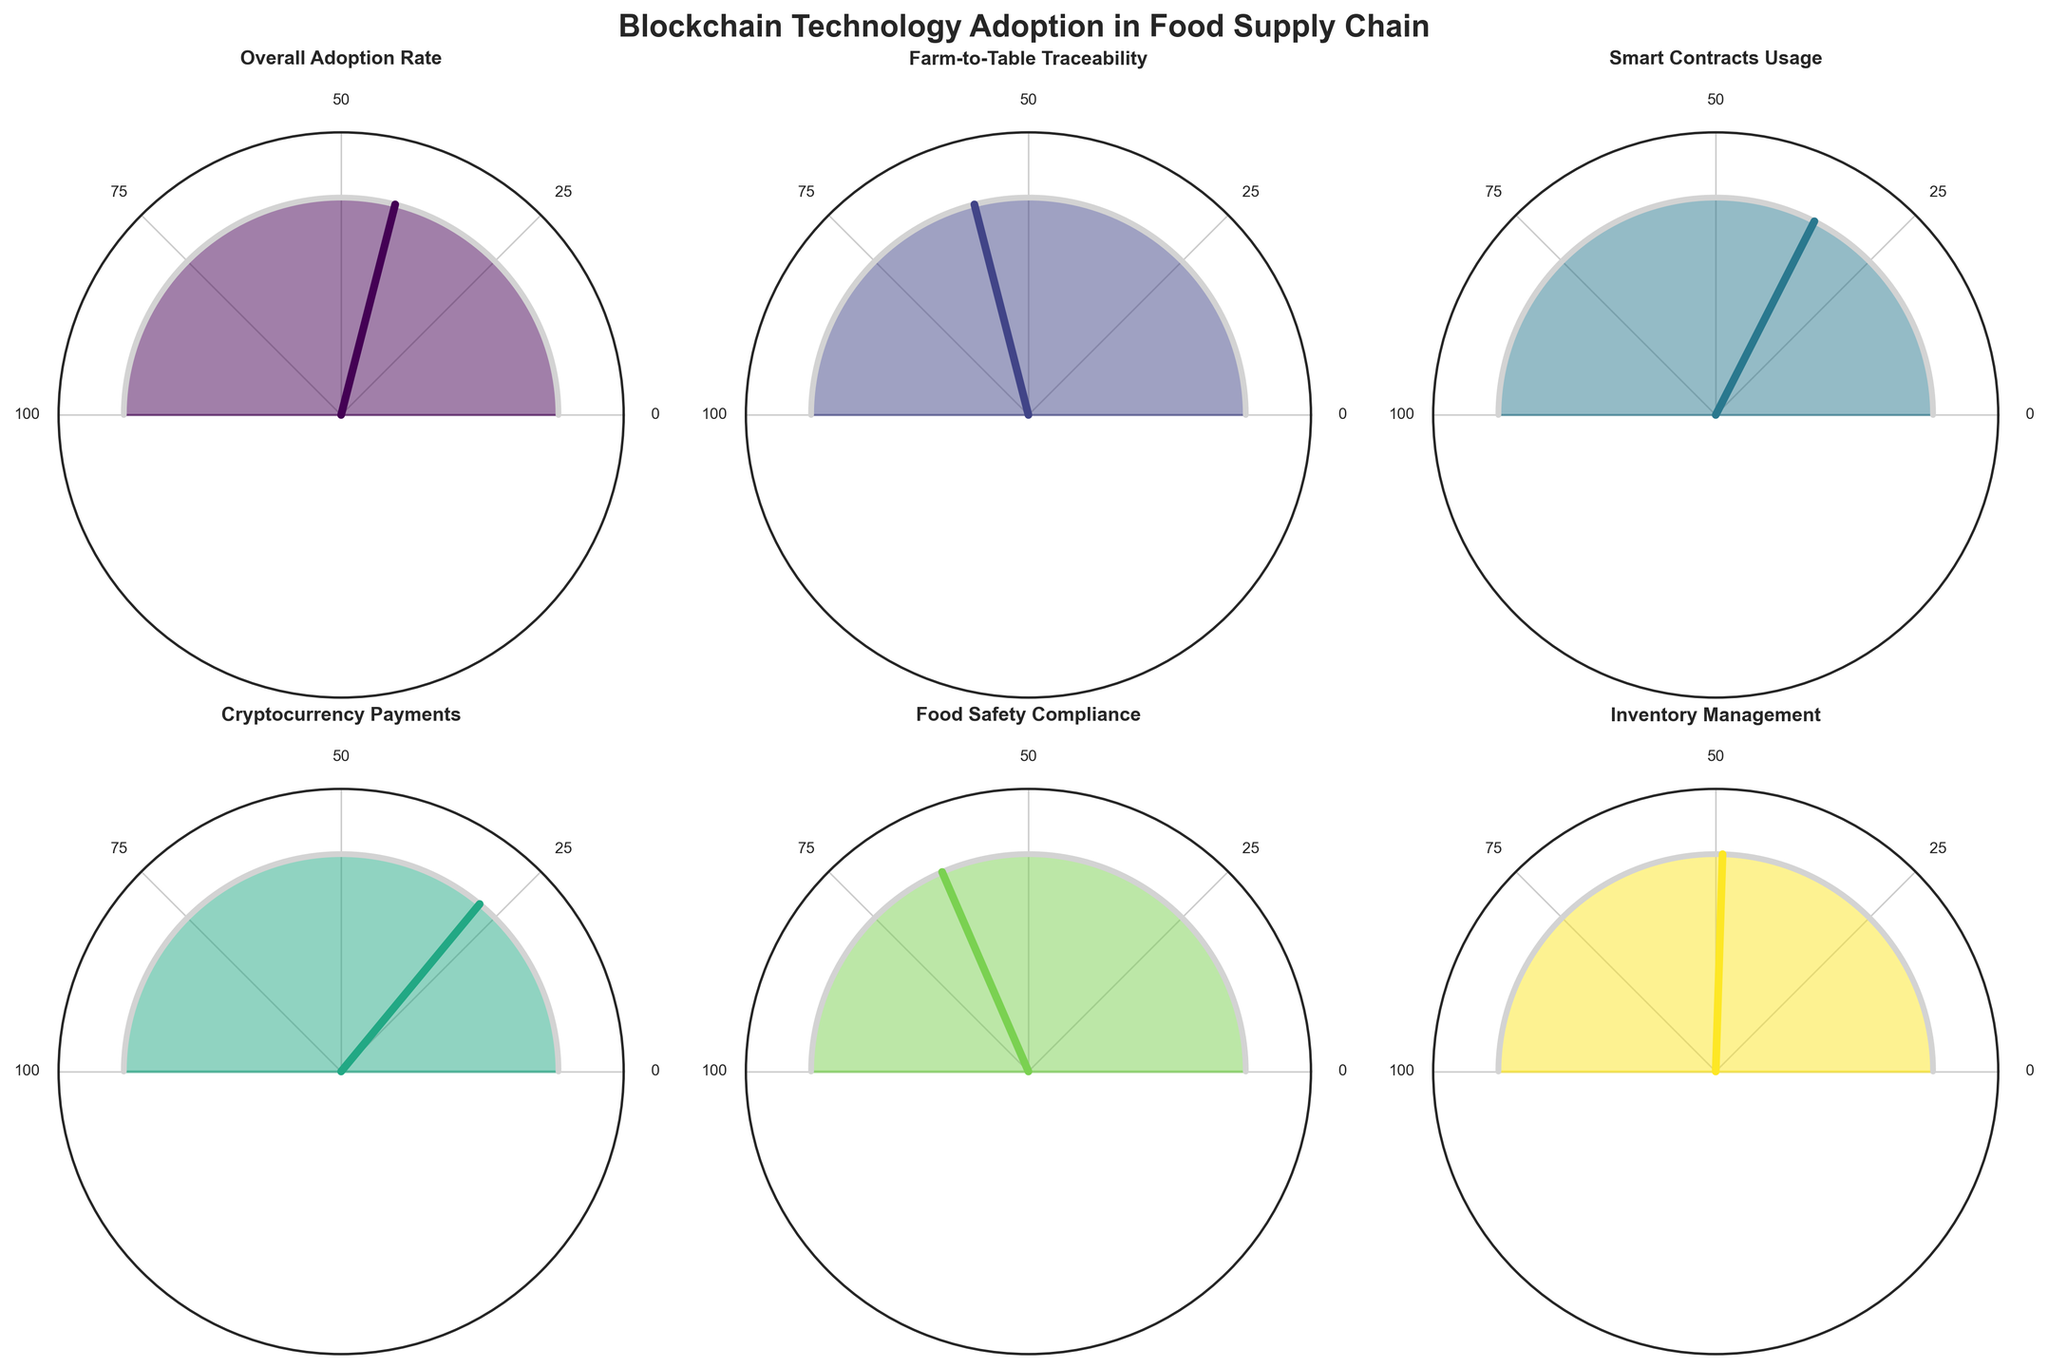How many categories are displayed in the figure? There are 6 gauge charts displayed in the figure, each representing a different category related to blockchain technology adoption in the food supply chain.
Answer: 6 What is the title of the figure? The title located at the top center of the figure is 'Blockchain Technology Adoption in Food Supply Chain'.
Answer: Blockchain Technology Adoption in Food Supply Chain Which category has the highest adoption rate? By examining the values associated with each gauge, we notice that 'Food Safety Compliance' has the highest adoption rate of 63%.
Answer: Food Safety Compliance Which category has the lowest adoption rate for blockchain technology? The category with the lowest value on its gauge is 'Cryptocurrency Payments', with an adoption rate of 28%.
Answer: Cryptocurrency Payments What is the combined adoption rate of 'Farm-to-Table Traceability' and 'Smart Contracts Usage'? Add the adoption rates of both categories: 58% (Farm-to-Table Traceability) + 35% (Smart Contracts Usage) = 93%.
Answer: 93% What is the average adoption rate across all categories? Sum the values of all categories (42 + 58 + 35 + 28 + 63 + 49) = 275 and divide by the number of categories, which is 6. So, the average adoption rate is 275/6 ≈ 45.83%.
Answer: 45.83% Which categories have an adoption rate higher than 50%? The categories with values on their gauges exceeding 50% are 'Farm-to-Table Traceability' (58%) and 'Food Safety Compliance' (63%).
Answer: Farm-to-Table Traceability, Food Safety Compliance How much higher is the adoption rate of 'Inventory Management' compared to 'Cryptocurrency Payments'? Subtract the adoption rate of 'Cryptocurrency Payments' (28%) from 'Inventory Management' (49%): 49% - 28% = 21%.
Answer: 21% What is the median adoption rate of the categories? Order the adoption rates: 28, 35, 42, 49, 58, 63. The median is the average of the two middle values (42 and 49), so (42 + 49) / 2 = 45.5%.
Answer: 45.5% Which gauge shows a value closest to 40%? By examining the values, 'Overall Adoption Rate' has an adoption rate of 42%, which is closest to 40%.
Answer: Overall Adoption Rate 